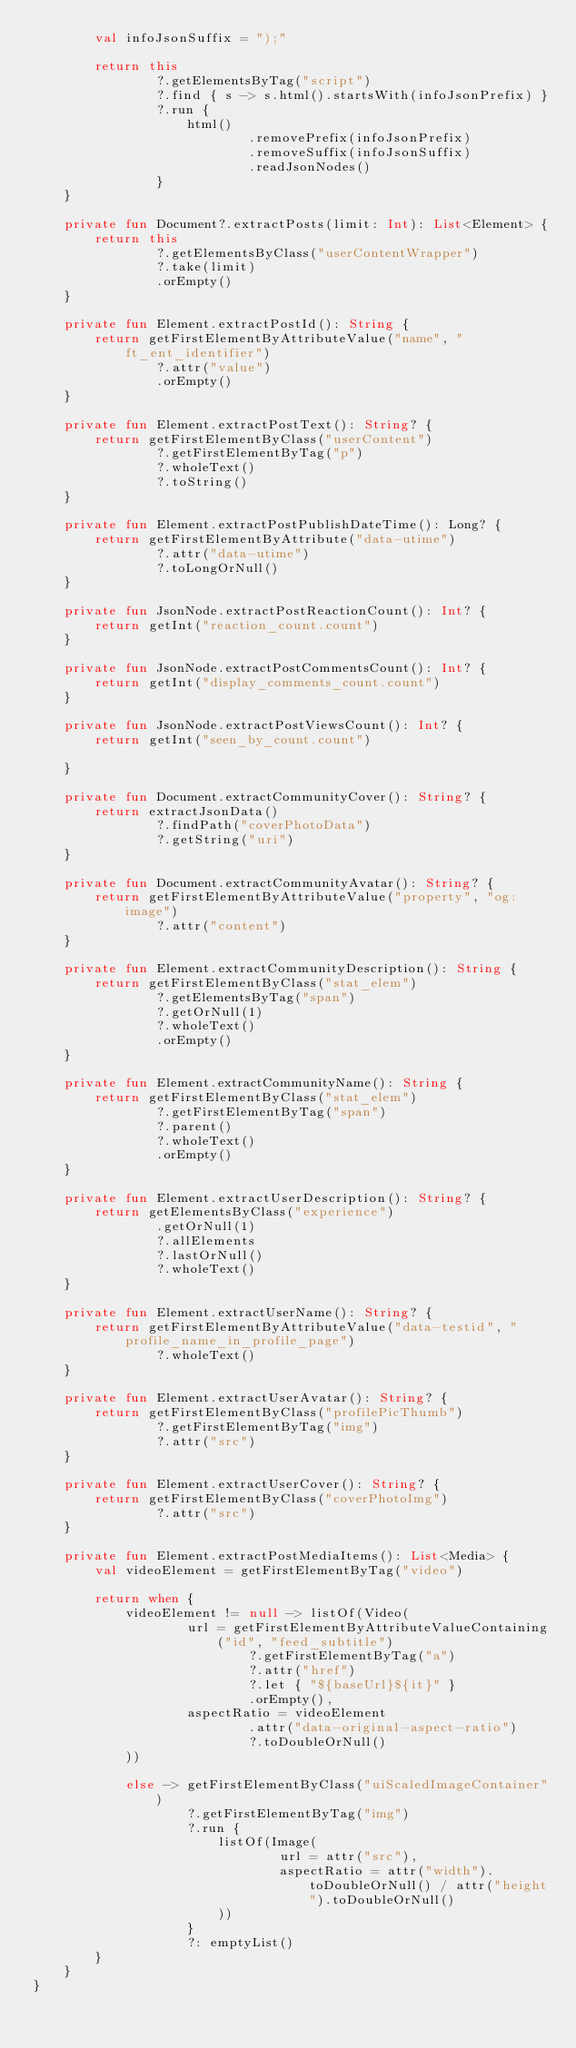<code> <loc_0><loc_0><loc_500><loc_500><_Kotlin_>        val infoJsonSuffix = ");"

        return this
                ?.getElementsByTag("script")
                ?.find { s -> s.html().startsWith(infoJsonPrefix) }
                ?.run {
                    html()
                            .removePrefix(infoJsonPrefix)
                            .removeSuffix(infoJsonSuffix)
                            .readJsonNodes()
                }
    }

    private fun Document?.extractPosts(limit: Int): List<Element> {
        return this
                ?.getElementsByClass("userContentWrapper")
                ?.take(limit)
                .orEmpty()
    }

    private fun Element.extractPostId(): String {
        return getFirstElementByAttributeValue("name", "ft_ent_identifier")
                ?.attr("value")
                .orEmpty()
    }

    private fun Element.extractPostText(): String? {
        return getFirstElementByClass("userContent")
                ?.getFirstElementByTag("p")
                ?.wholeText()
                ?.toString()
    }

    private fun Element.extractPostPublishDateTime(): Long? {
        return getFirstElementByAttribute("data-utime")
                ?.attr("data-utime")
                ?.toLongOrNull()
    }

    private fun JsonNode.extractPostReactionCount(): Int? {
        return getInt("reaction_count.count")
    }

    private fun JsonNode.extractPostCommentsCount(): Int? {
        return getInt("display_comments_count.count")
    }

    private fun JsonNode.extractPostViewsCount(): Int? {
        return getInt("seen_by_count.count")

    }

    private fun Document.extractCommunityCover(): String? {
        return extractJsonData()
                ?.findPath("coverPhotoData")
                ?.getString("uri")
    }

    private fun Document.extractCommunityAvatar(): String? {
        return getFirstElementByAttributeValue("property", "og:image")
                ?.attr("content")
    }

    private fun Element.extractCommunityDescription(): String {
        return getFirstElementByClass("stat_elem")
                ?.getElementsByTag("span")
                ?.getOrNull(1)
                ?.wholeText()
                .orEmpty()
    }

    private fun Element.extractCommunityName(): String {
        return getFirstElementByClass("stat_elem")
                ?.getFirstElementByTag("span")
                ?.parent()
                ?.wholeText()
                .orEmpty()
    }

    private fun Element.extractUserDescription(): String? {
        return getElementsByClass("experience")
                .getOrNull(1)
                ?.allElements
                ?.lastOrNull()
                ?.wholeText()
    }

    private fun Element.extractUserName(): String? {
        return getFirstElementByAttributeValue("data-testid", "profile_name_in_profile_page")
                ?.wholeText()
    }

    private fun Element.extractUserAvatar(): String? {
        return getFirstElementByClass("profilePicThumb")
                ?.getFirstElementByTag("img")
                ?.attr("src")
    }

    private fun Element.extractUserCover(): String? {
        return getFirstElementByClass("coverPhotoImg")
                ?.attr("src")
    }

    private fun Element.extractPostMediaItems(): List<Media> {
        val videoElement = getFirstElementByTag("video")

        return when {
            videoElement != null -> listOf(Video(
                    url = getFirstElementByAttributeValueContaining("id", "feed_subtitle")
                            ?.getFirstElementByTag("a")
                            ?.attr("href")
                            ?.let { "${baseUrl}${it}" }
                            .orEmpty(),
                    aspectRatio = videoElement
                            .attr("data-original-aspect-ratio")
                            ?.toDoubleOrNull()
            ))

            else -> getFirstElementByClass("uiScaledImageContainer")
                    ?.getFirstElementByTag("img")
                    ?.run {
                        listOf(Image(
                                url = attr("src"),
                                aspectRatio = attr("width").toDoubleOrNull() / attr("height").toDoubleOrNull()
                        ))
                    }
                    ?: emptyList()
        }
    }
}</code> 